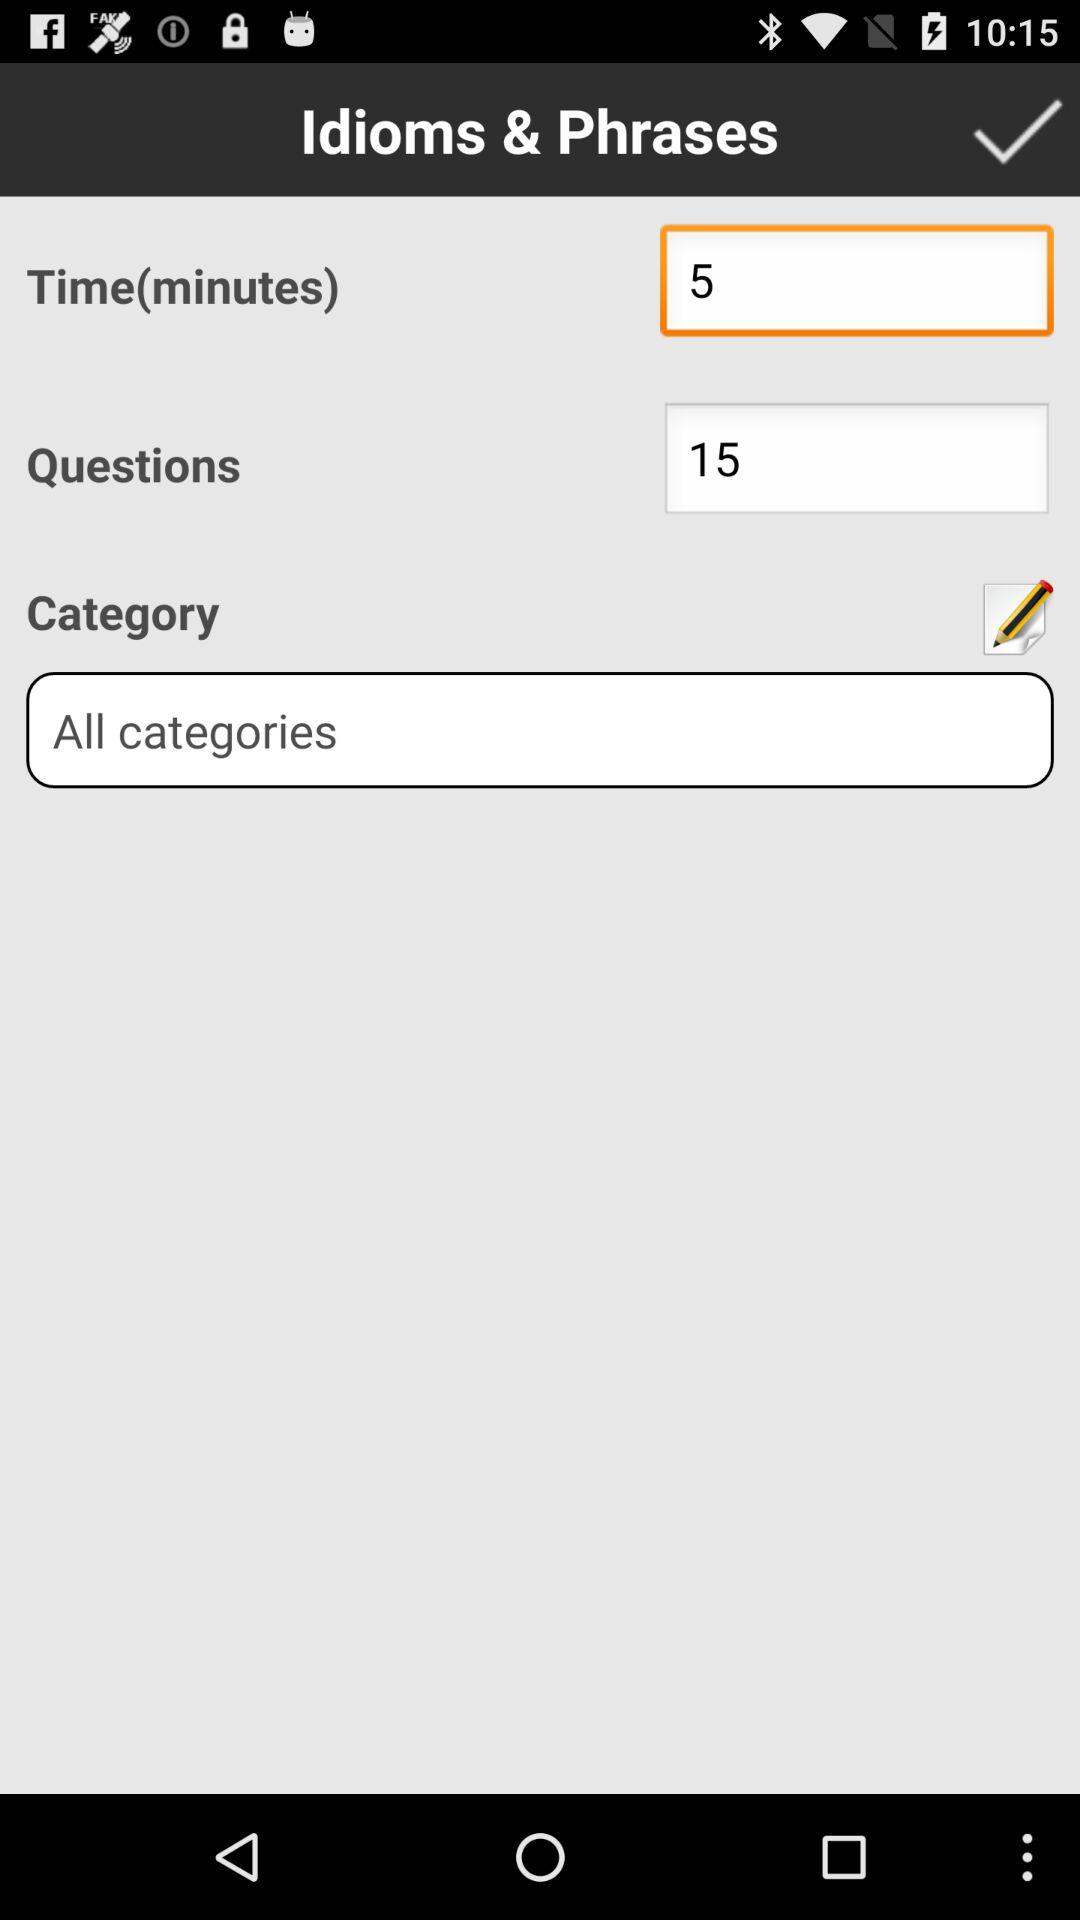How many more questions are there than minutes?
Answer the question using a single word or phrase. 10 